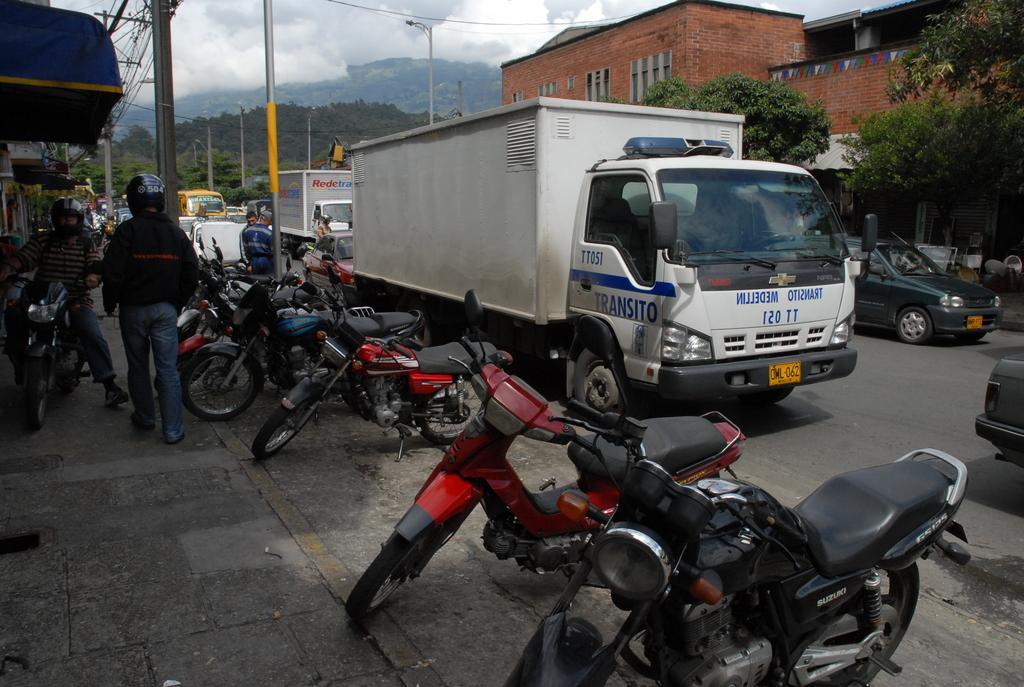Can you describe this image briefly? In this image I can see few vehicles on the road. In front I can see few persons, background I can see few light poles, buildings in brown color , trees in green color and the sky is in white color. 